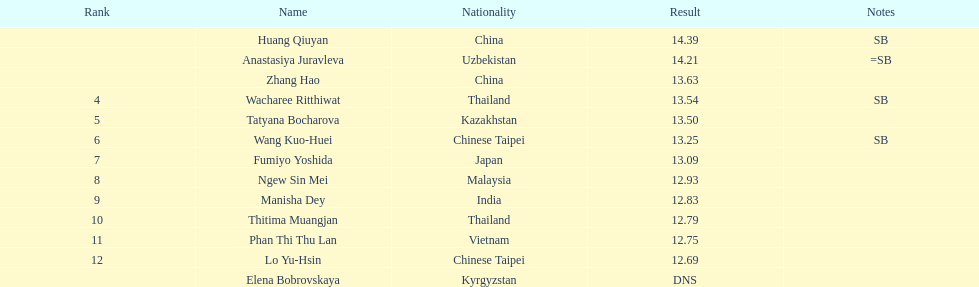Which nation had the highest number of participants ranked in the top three in the event? China. 